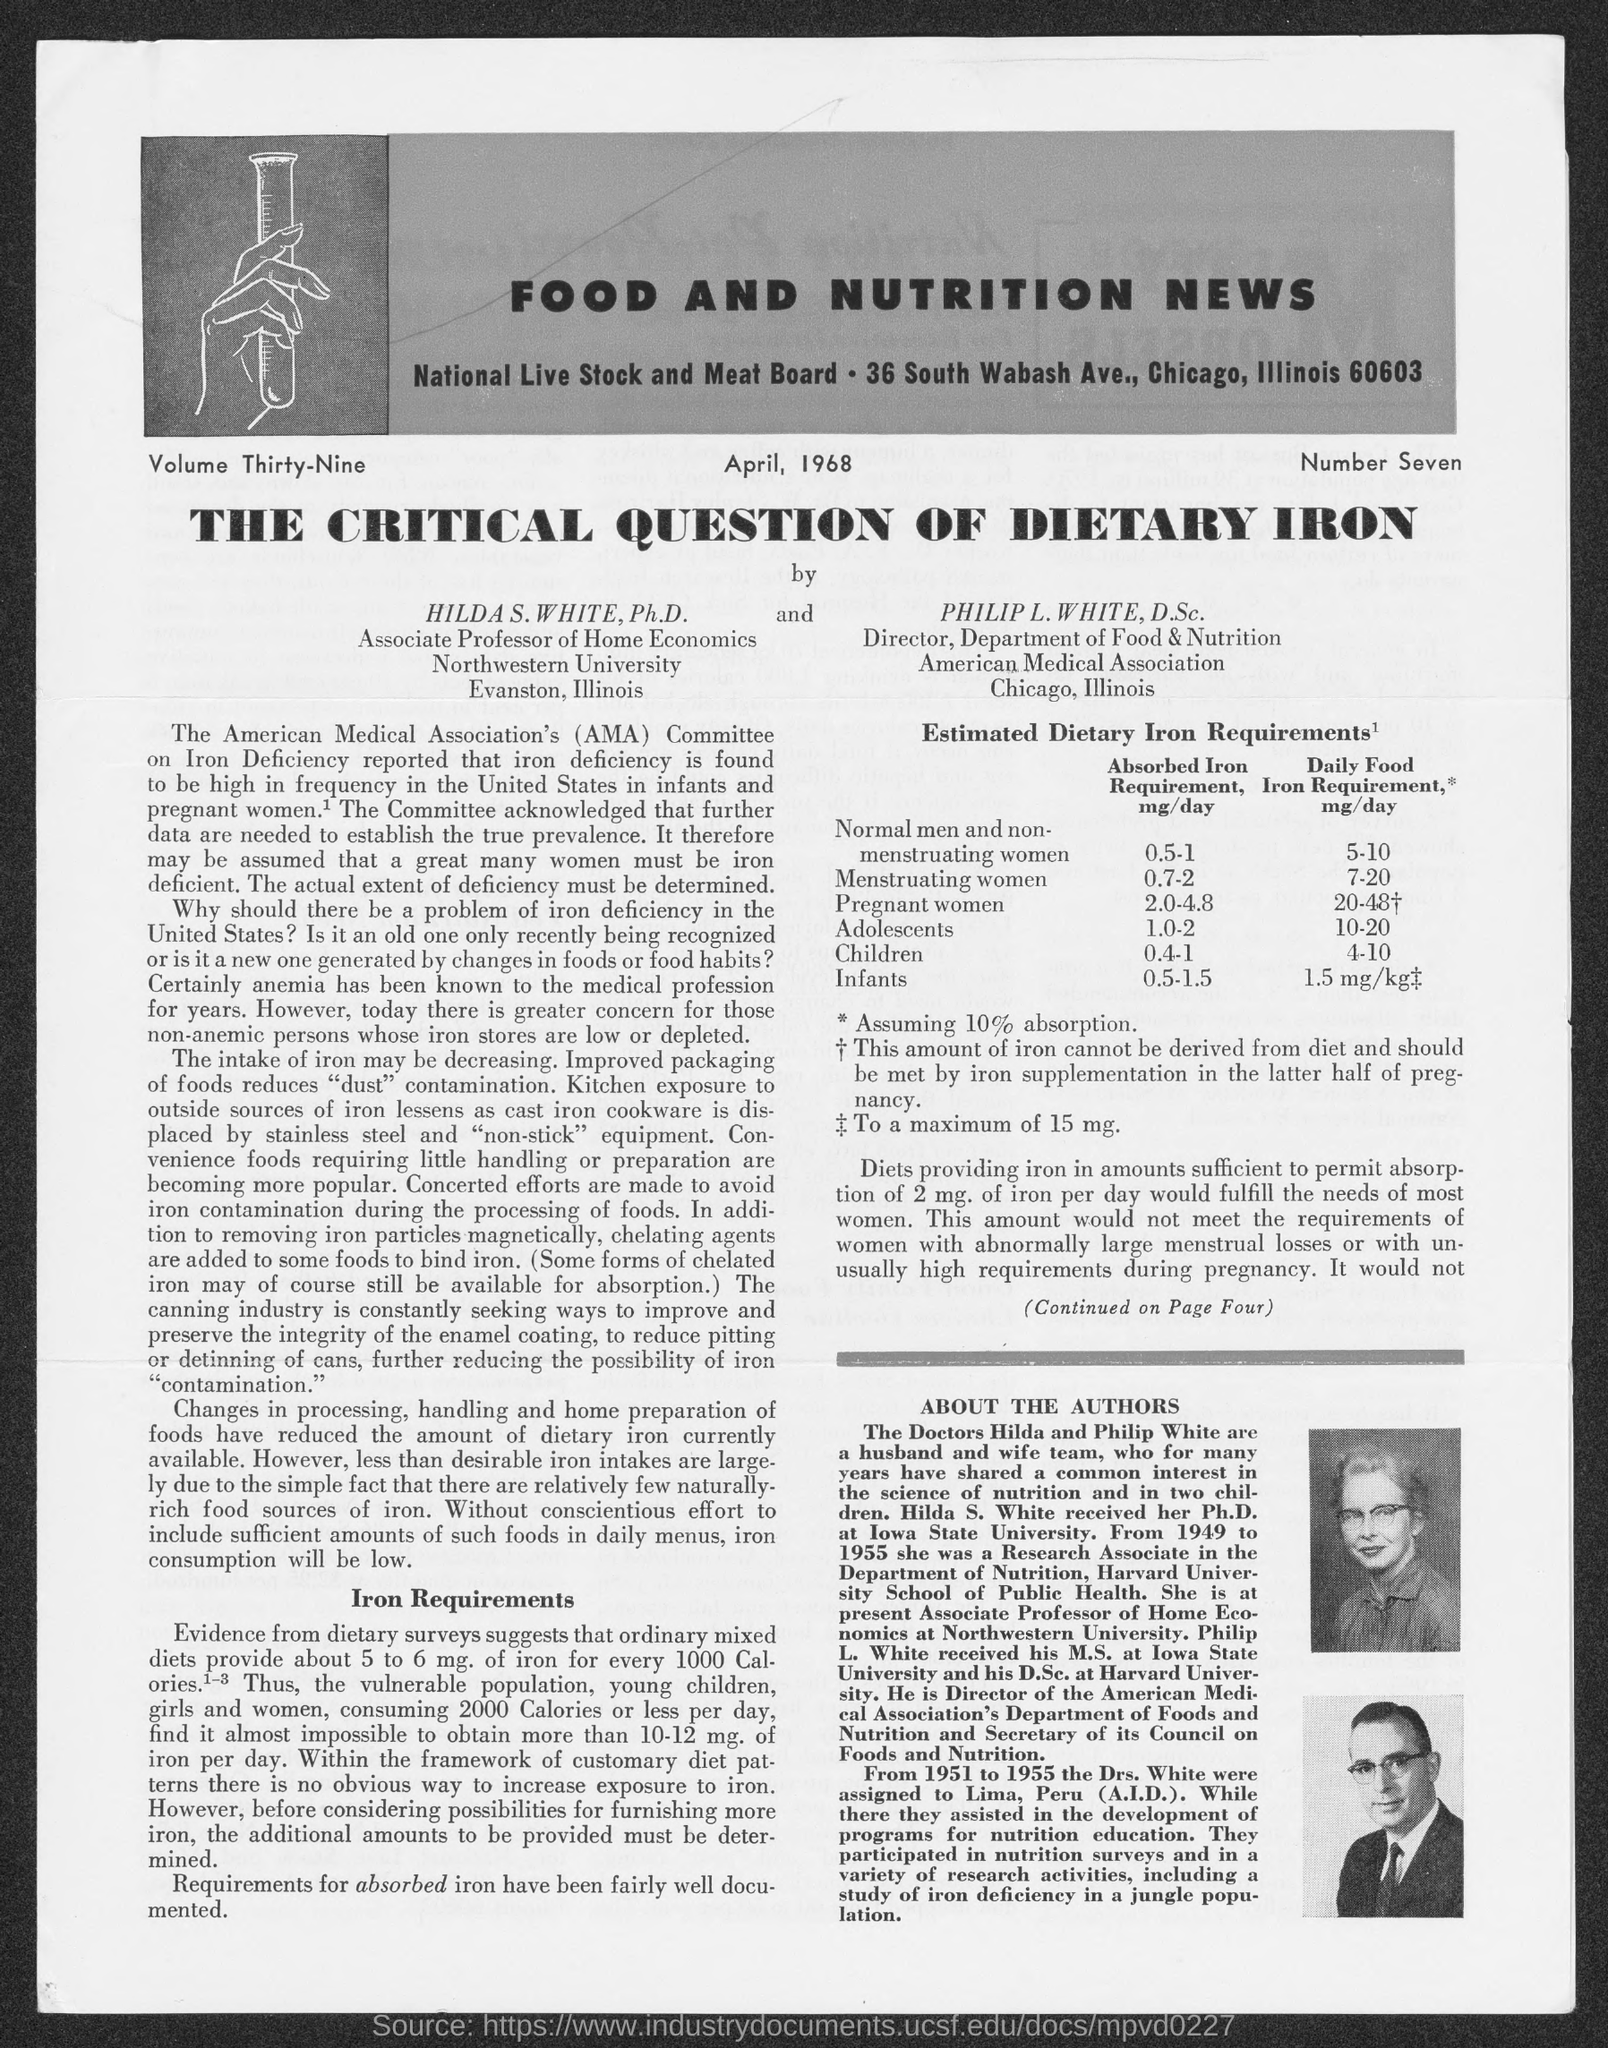Specify some key components in this picture. The critical question is about dietary iron. I hereby declare that the name of the news is FOOD AND NUTRITION NEWS. 